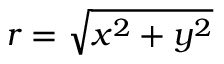Convert formula to latex. <formula><loc_0><loc_0><loc_500><loc_500>r = \sqrt { x ^ { 2 } + y ^ { 2 } }</formula> 